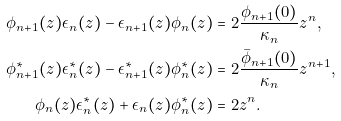Convert formula to latex. <formula><loc_0><loc_0><loc_500><loc_500>\phi _ { n + 1 } ( z ) \epsilon _ { n } ( z ) - \epsilon _ { n + 1 } ( z ) \phi _ { n } ( z ) & = 2 \frac { \phi _ { n + 1 } ( 0 ) } { \kappa _ { n } } z ^ { n } , \\ \phi ^ { * } _ { n + 1 } ( z ) \epsilon ^ { * } _ { n } ( z ) - \epsilon ^ { * } _ { n + 1 } ( z ) \phi ^ { * } _ { n } ( z ) & = 2 \frac { \bar { \phi } _ { n + 1 } ( 0 ) } { \kappa _ { n } } z ^ { n + 1 } , \\ \phi _ { n } ( z ) \epsilon ^ { * } _ { n } ( z ) + \epsilon _ { n } ( z ) \phi ^ { * } _ { n } ( z ) & = 2 z ^ { n } .</formula> 